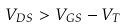<formula> <loc_0><loc_0><loc_500><loc_500>V _ { D S } > V _ { G S } - V _ { T }</formula> 